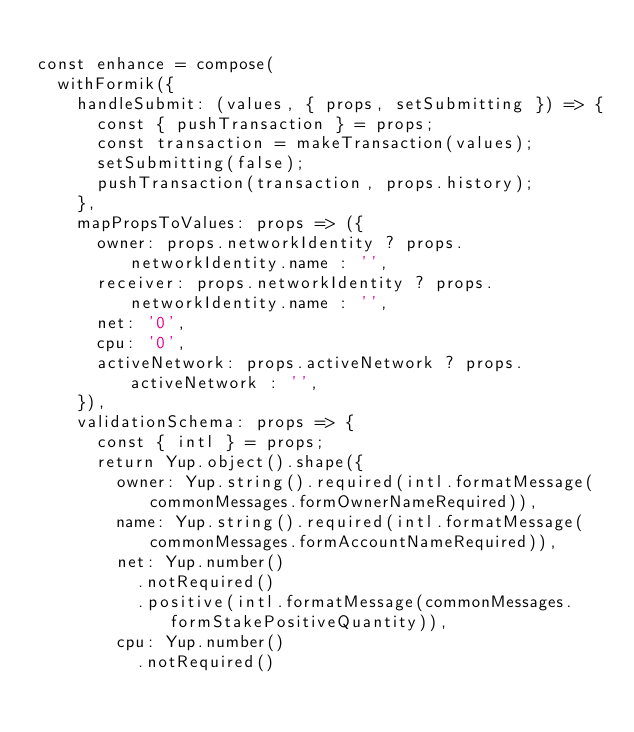<code> <loc_0><loc_0><loc_500><loc_500><_JavaScript_>
const enhance = compose(
  withFormik({
    handleSubmit: (values, { props, setSubmitting }) => {
      const { pushTransaction } = props;
      const transaction = makeTransaction(values);
      setSubmitting(false);
      pushTransaction(transaction, props.history);
    },
    mapPropsToValues: props => ({
      owner: props.networkIdentity ? props.networkIdentity.name : '',
      receiver: props.networkIdentity ? props.networkIdentity.name : '',
      net: '0',
      cpu: '0',
      activeNetwork: props.activeNetwork ? props.activeNetwork : '',
    }),
    validationSchema: props => {
      const { intl } = props;
      return Yup.object().shape({
        owner: Yup.string().required(intl.formatMessage(commonMessages.formOwnerNameRequired)),
        name: Yup.string().required(intl.formatMessage(commonMessages.formAccountNameRequired)),
        net: Yup.number()
          .notRequired()
          .positive(intl.formatMessage(commonMessages.formStakePositiveQuantity)),
        cpu: Yup.number()
          .notRequired()</code> 